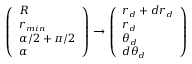Convert formula to latex. <formula><loc_0><loc_0><loc_500><loc_500>\left ( \begin{array} { l } { R } \\ { r _ { \min } } \\ { \alpha / 2 + \pi / 2 } \\ { \alpha } \end{array} \right ) \to \left ( \begin{array} { l } { r _ { d } + d r _ { d } } \\ { r _ { d } } \\ { \theta _ { d } } \\ { d \theta _ { d } } \end{array} \right )</formula> 